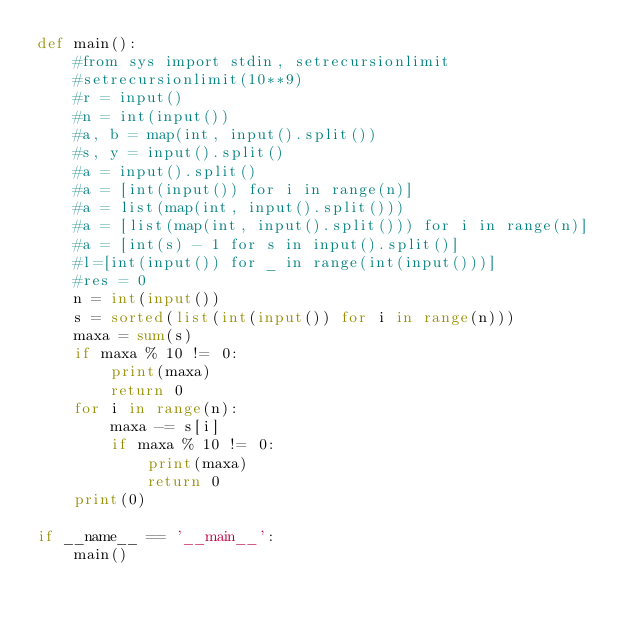Convert code to text. <code><loc_0><loc_0><loc_500><loc_500><_Python_>def main():
    #from sys import stdin, setrecursionlimit
    #setrecursionlimit(10**9)
    #r = input()
    #n = int(input())
    #a, b = map(int, input().split())
    #s, y = input().split()
    #a = input().split()
    #a = [int(input()) for i in range(n)]
    #a = list(map(int, input().split()))
    #a = [list(map(int, input().split())) for i in range(n)]
    #a = [int(s) - 1 for s in input().split()]
    #l=[int(input()) for _ in range(int(input()))]
    #res = 0
    n = int(input())
    s = sorted(list(int(input()) for i in range(n)))
    maxa = sum(s)
    if maxa % 10 != 0:
        print(maxa)
        return 0
    for i in range(n):
        maxa -= s[i]
        if maxa % 10 != 0:
            print(maxa)
            return 0
    print(0)
       
if __name__ == '__main__':
    main()

</code> 